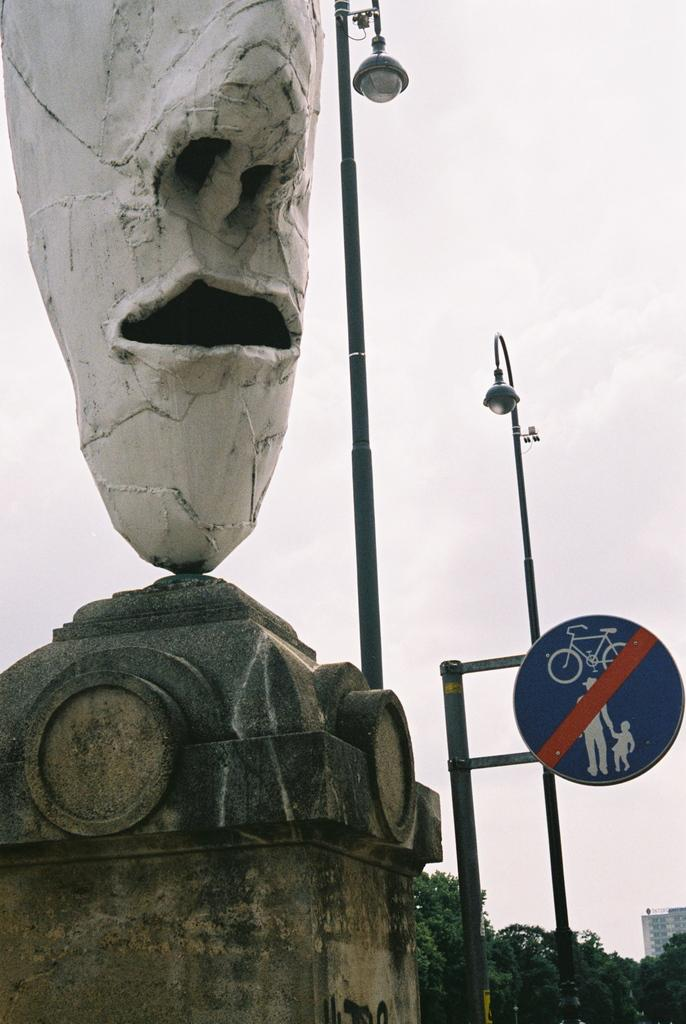What is the main subject in the image? There is a sculpture in the image. What can be seen in the background of the image? There are lights, a sign board, trees, and a building in the background of the image. What is the price of the zephyr in the image? There is no zephyr present in the image, so it is not possible to determine its price. 